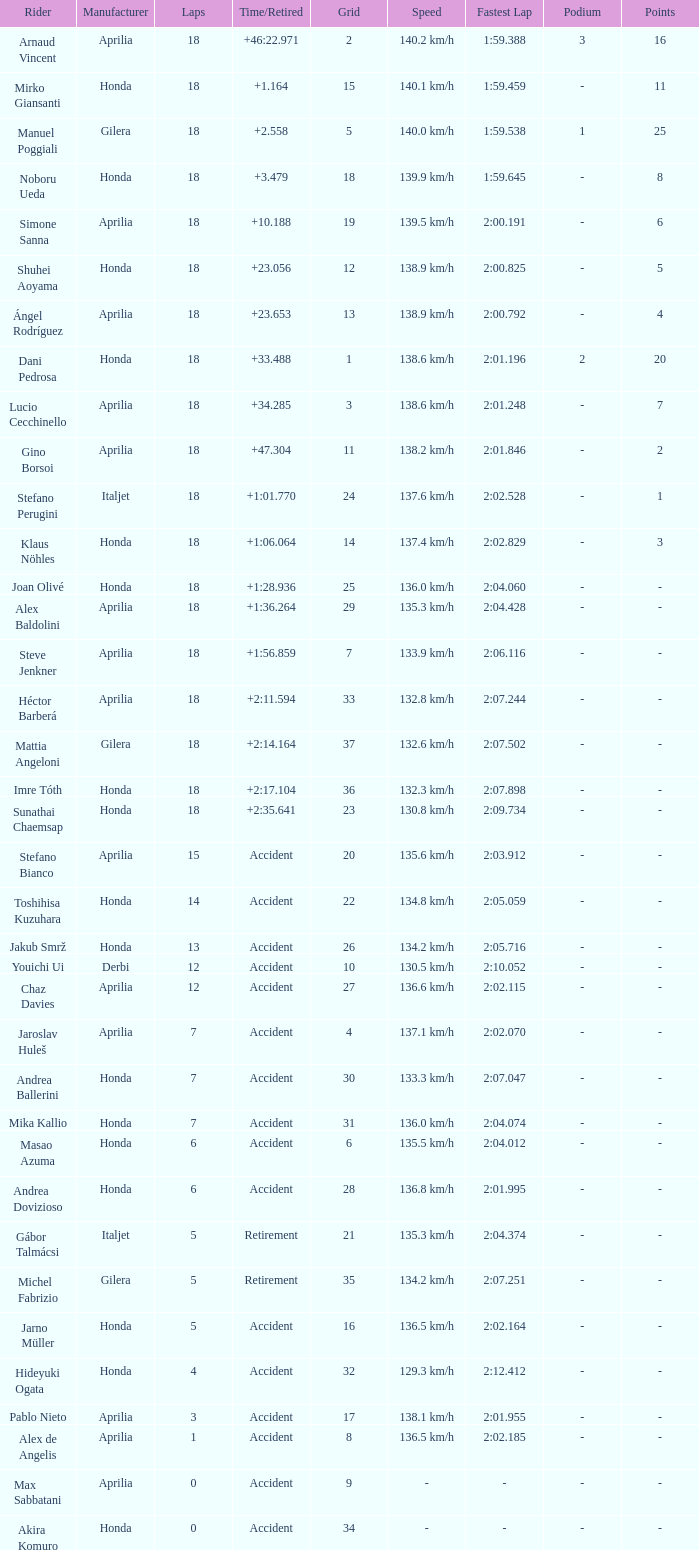What is the time/retired of the honda manufacturer with a grid less than 26, 18 laps, and joan olivé as the rider? +1:28.936. 